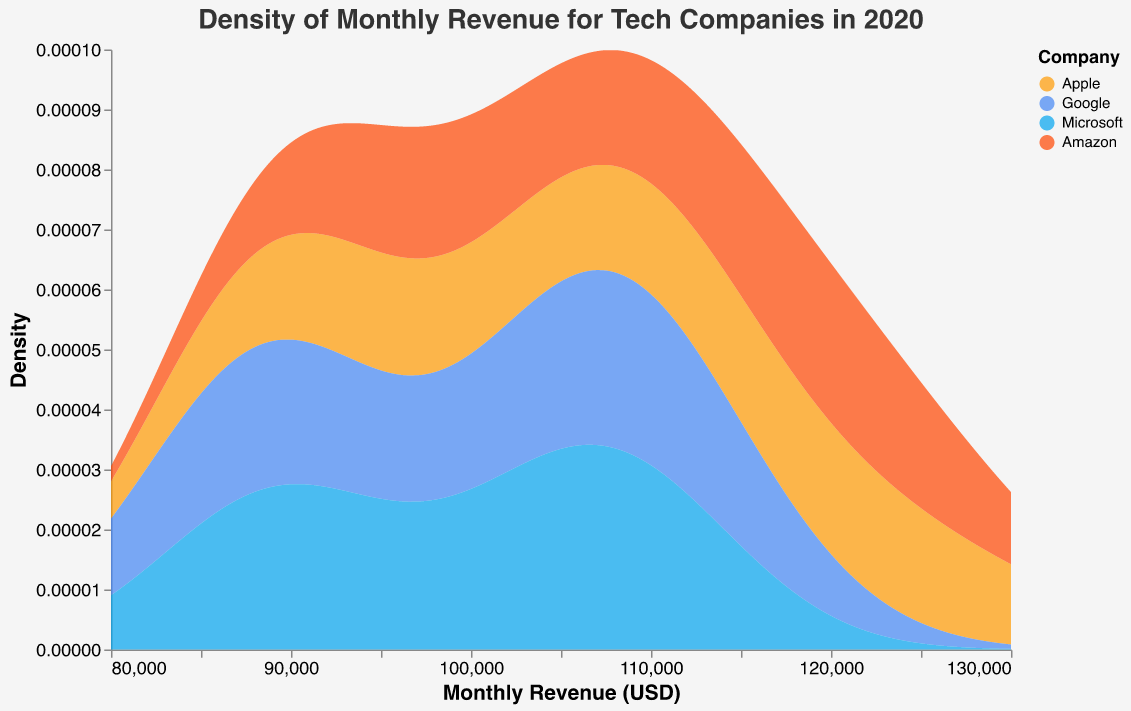What is the title of the density plot? The title is located at the top of the figure. It typically summarizes the overall content of the plot.
Answer: Density of Monthly Revenue for Tech Companies in 2020 What does the x-axis represent? The labels on the x-axis reveal its meaning.
Answer: Monthly Revenue (USD) Which companies are included in the plot? The legend displays which companies are represented by different colors.
Answer: Apple, Google, Microsoft, Amazon What color represents Apple in the plot? The legend associates each company with a specific color.
Answer: Orange Which company has the highest density peak for monthly revenue around $115,000? Identify the company with the highest peak on the plot near the $115,000 mark on the x-axis.
Answer: Apple Which company shows the most varied distribution in monthly revenue? By observing the width and spread of the density plots, identify the company with the broadest range.
Answer: Amazon How does Amazon's monthly revenue distribution compare to Microsoft's in terms of spread? Compare the width and spread of the density plots for Amazon and Microsoft.
Answer: Amazon’s spread is wider compared to Microsoft's, indicating more variability What is the approximate monthly revenue range where Google's density peak appears? Check the plot to see where Google’s highest density value is along the x-axis.
Answer: Around $108,000 to $114,000 At which approximate monthly revenue value do Apple and Amazon have similar densities? Locate where the density curves of Apple and Amazon intersect or appear closely aligned.
Answer: Around $120,000 What does the y-axis represent in this plot? The labels on the y-axis describe what is measured.
Answer: Density 